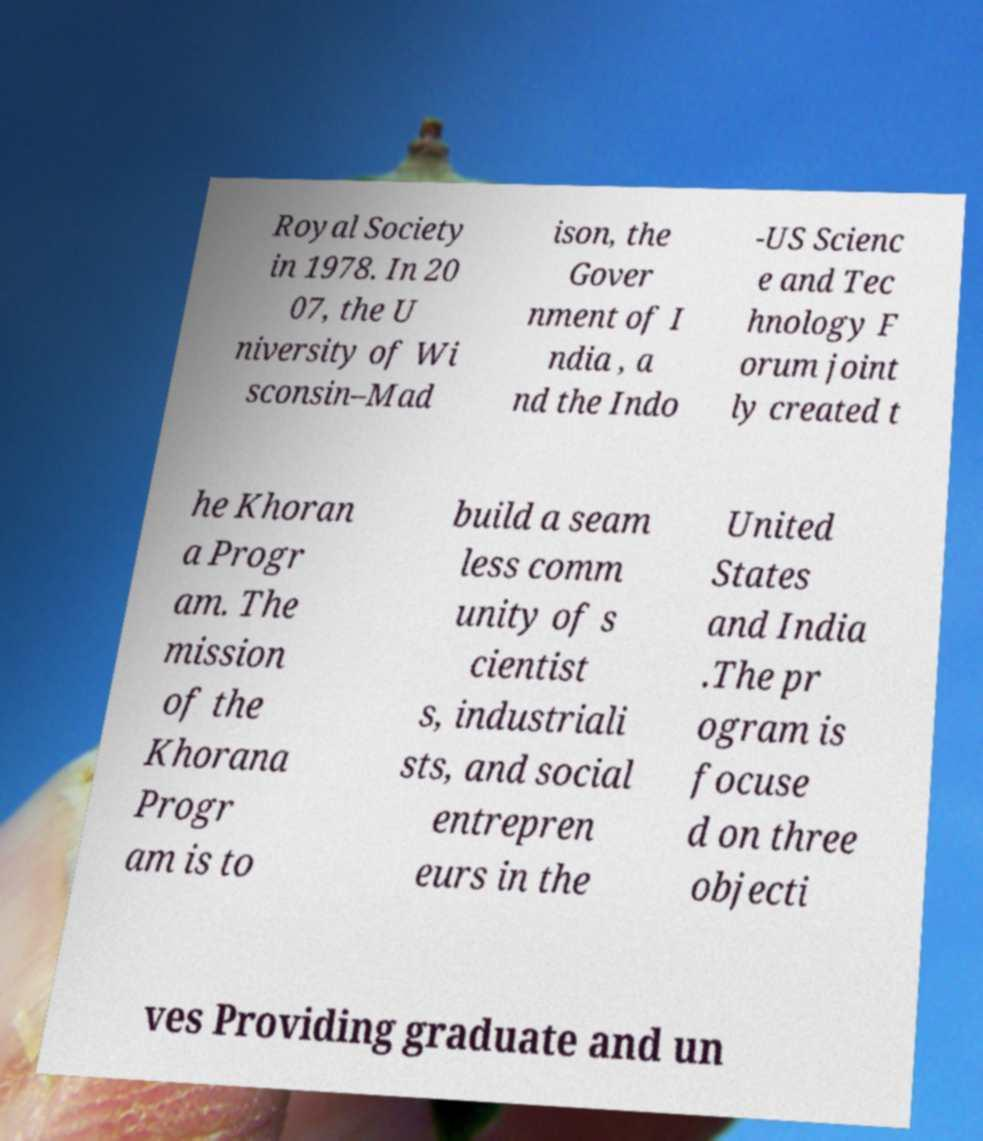Please read and relay the text visible in this image. What does it say? Royal Society in 1978. In 20 07, the U niversity of Wi sconsin–Mad ison, the Gover nment of I ndia , a nd the Indo -US Scienc e and Tec hnology F orum joint ly created t he Khoran a Progr am. The mission of the Khorana Progr am is to build a seam less comm unity of s cientist s, industriali sts, and social entrepren eurs in the United States and India .The pr ogram is focuse d on three objecti ves Providing graduate and un 